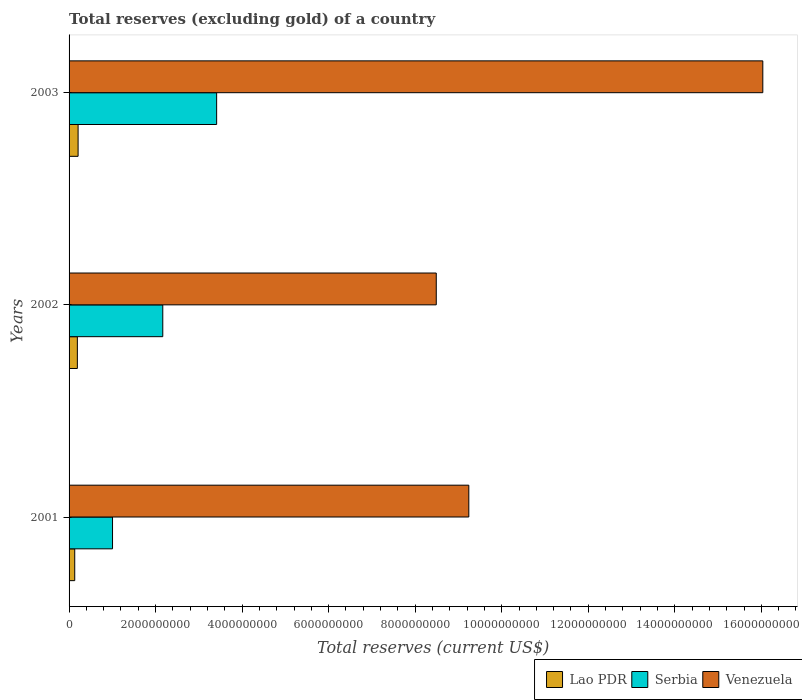How many groups of bars are there?
Offer a very short reply. 3. Are the number of bars per tick equal to the number of legend labels?
Keep it short and to the point. Yes. In how many cases, is the number of bars for a given year not equal to the number of legend labels?
Your response must be concise. 0. What is the total reserves (excluding gold) in Lao PDR in 2001?
Ensure brevity in your answer.  1.31e+08. Across all years, what is the maximum total reserves (excluding gold) in Venezuela?
Keep it short and to the point. 1.60e+1. Across all years, what is the minimum total reserves (excluding gold) in Serbia?
Provide a succinct answer. 1.00e+09. In which year was the total reserves (excluding gold) in Serbia maximum?
Your answer should be very brief. 2003. In which year was the total reserves (excluding gold) in Lao PDR minimum?
Offer a very short reply. 2001. What is the total total reserves (excluding gold) in Serbia in the graph?
Your answer should be compact. 6.58e+09. What is the difference between the total reserves (excluding gold) in Serbia in 2001 and that in 2003?
Ensure brevity in your answer.  -2.41e+09. What is the difference between the total reserves (excluding gold) in Venezuela in 2003 and the total reserves (excluding gold) in Lao PDR in 2002?
Ensure brevity in your answer.  1.58e+1. What is the average total reserves (excluding gold) in Lao PDR per year?
Make the answer very short. 1.77e+08. In the year 2001, what is the difference between the total reserves (excluding gold) in Serbia and total reserves (excluding gold) in Lao PDR?
Keep it short and to the point. 8.74e+08. What is the ratio of the total reserves (excluding gold) in Serbia in 2001 to that in 2003?
Keep it short and to the point. 0.29. Is the total reserves (excluding gold) in Lao PDR in 2001 less than that in 2003?
Provide a short and direct response. Yes. What is the difference between the highest and the second highest total reserves (excluding gold) in Venezuela?
Offer a terse response. 6.80e+09. What is the difference between the highest and the lowest total reserves (excluding gold) in Serbia?
Your response must be concise. 2.41e+09. In how many years, is the total reserves (excluding gold) in Venezuela greater than the average total reserves (excluding gold) in Venezuela taken over all years?
Ensure brevity in your answer.  1. Is the sum of the total reserves (excluding gold) in Venezuela in 2001 and 2002 greater than the maximum total reserves (excluding gold) in Lao PDR across all years?
Make the answer very short. Yes. What does the 2nd bar from the top in 2003 represents?
Provide a succinct answer. Serbia. What does the 2nd bar from the bottom in 2001 represents?
Ensure brevity in your answer.  Serbia. Is it the case that in every year, the sum of the total reserves (excluding gold) in Serbia and total reserves (excluding gold) in Lao PDR is greater than the total reserves (excluding gold) in Venezuela?
Provide a succinct answer. No. What is the difference between two consecutive major ticks on the X-axis?
Give a very brief answer. 2.00e+09. Are the values on the major ticks of X-axis written in scientific E-notation?
Ensure brevity in your answer.  No. Does the graph contain any zero values?
Ensure brevity in your answer.  No. How are the legend labels stacked?
Ensure brevity in your answer.  Horizontal. What is the title of the graph?
Offer a very short reply. Total reserves (excluding gold) of a country. What is the label or title of the X-axis?
Provide a succinct answer. Total reserves (current US$). What is the label or title of the Y-axis?
Offer a very short reply. Years. What is the Total reserves (current US$) in Lao PDR in 2001?
Offer a terse response. 1.31e+08. What is the Total reserves (current US$) in Serbia in 2001?
Provide a short and direct response. 1.00e+09. What is the Total reserves (current US$) of Venezuela in 2001?
Ensure brevity in your answer.  9.24e+09. What is the Total reserves (current US$) of Lao PDR in 2002?
Keep it short and to the point. 1.92e+08. What is the Total reserves (current US$) in Serbia in 2002?
Offer a very short reply. 2.17e+09. What is the Total reserves (current US$) of Venezuela in 2002?
Your answer should be compact. 8.49e+09. What is the Total reserves (current US$) of Lao PDR in 2003?
Offer a terse response. 2.09e+08. What is the Total reserves (current US$) in Serbia in 2003?
Your response must be concise. 3.41e+09. What is the Total reserves (current US$) of Venezuela in 2003?
Provide a short and direct response. 1.60e+1. Across all years, what is the maximum Total reserves (current US$) in Lao PDR?
Provide a short and direct response. 2.09e+08. Across all years, what is the maximum Total reserves (current US$) of Serbia?
Give a very brief answer. 3.41e+09. Across all years, what is the maximum Total reserves (current US$) of Venezuela?
Provide a short and direct response. 1.60e+1. Across all years, what is the minimum Total reserves (current US$) of Lao PDR?
Your response must be concise. 1.31e+08. Across all years, what is the minimum Total reserves (current US$) in Serbia?
Ensure brevity in your answer.  1.00e+09. Across all years, what is the minimum Total reserves (current US$) in Venezuela?
Offer a terse response. 8.49e+09. What is the total Total reserves (current US$) of Lao PDR in the graph?
Your response must be concise. 5.31e+08. What is the total Total reserves (current US$) in Serbia in the graph?
Give a very brief answer. 6.58e+09. What is the total Total reserves (current US$) of Venezuela in the graph?
Your answer should be very brief. 3.38e+1. What is the difference between the Total reserves (current US$) of Lao PDR in 2001 and that in 2002?
Provide a short and direct response. -6.07e+07. What is the difference between the Total reserves (current US$) of Serbia in 2001 and that in 2002?
Offer a terse response. -1.16e+09. What is the difference between the Total reserves (current US$) in Venezuela in 2001 and that in 2002?
Ensure brevity in your answer.  7.52e+08. What is the difference between the Total reserves (current US$) of Lao PDR in 2001 and that in 2003?
Ensure brevity in your answer.  -7.77e+07. What is the difference between the Total reserves (current US$) of Serbia in 2001 and that in 2003?
Your response must be concise. -2.41e+09. What is the difference between the Total reserves (current US$) in Venezuela in 2001 and that in 2003?
Ensure brevity in your answer.  -6.80e+09. What is the difference between the Total reserves (current US$) of Lao PDR in 2002 and that in 2003?
Your response must be concise. -1.70e+07. What is the difference between the Total reserves (current US$) of Serbia in 2002 and that in 2003?
Offer a very short reply. -1.24e+09. What is the difference between the Total reserves (current US$) of Venezuela in 2002 and that in 2003?
Keep it short and to the point. -7.55e+09. What is the difference between the Total reserves (current US$) in Lao PDR in 2001 and the Total reserves (current US$) in Serbia in 2002?
Your answer should be compact. -2.04e+09. What is the difference between the Total reserves (current US$) in Lao PDR in 2001 and the Total reserves (current US$) in Venezuela in 2002?
Give a very brief answer. -8.36e+09. What is the difference between the Total reserves (current US$) of Serbia in 2001 and the Total reserves (current US$) of Venezuela in 2002?
Ensure brevity in your answer.  -7.48e+09. What is the difference between the Total reserves (current US$) in Lao PDR in 2001 and the Total reserves (current US$) in Serbia in 2003?
Ensure brevity in your answer.  -3.28e+09. What is the difference between the Total reserves (current US$) of Lao PDR in 2001 and the Total reserves (current US$) of Venezuela in 2003?
Provide a short and direct response. -1.59e+1. What is the difference between the Total reserves (current US$) of Serbia in 2001 and the Total reserves (current US$) of Venezuela in 2003?
Your answer should be compact. -1.50e+1. What is the difference between the Total reserves (current US$) of Lao PDR in 2002 and the Total reserves (current US$) of Serbia in 2003?
Offer a very short reply. -3.22e+09. What is the difference between the Total reserves (current US$) of Lao PDR in 2002 and the Total reserves (current US$) of Venezuela in 2003?
Your answer should be very brief. -1.58e+1. What is the difference between the Total reserves (current US$) in Serbia in 2002 and the Total reserves (current US$) in Venezuela in 2003?
Offer a terse response. -1.39e+1. What is the average Total reserves (current US$) in Lao PDR per year?
Provide a succinct answer. 1.77e+08. What is the average Total reserves (current US$) in Serbia per year?
Give a very brief answer. 2.19e+09. What is the average Total reserves (current US$) of Venezuela per year?
Give a very brief answer. 1.13e+1. In the year 2001, what is the difference between the Total reserves (current US$) in Lao PDR and Total reserves (current US$) in Serbia?
Offer a very short reply. -8.74e+08. In the year 2001, what is the difference between the Total reserves (current US$) in Lao PDR and Total reserves (current US$) in Venezuela?
Your answer should be very brief. -9.11e+09. In the year 2001, what is the difference between the Total reserves (current US$) in Serbia and Total reserves (current US$) in Venezuela?
Give a very brief answer. -8.23e+09. In the year 2002, what is the difference between the Total reserves (current US$) in Lao PDR and Total reserves (current US$) in Serbia?
Offer a very short reply. -1.97e+09. In the year 2002, what is the difference between the Total reserves (current US$) in Lao PDR and Total reserves (current US$) in Venezuela?
Offer a very short reply. -8.30e+09. In the year 2002, what is the difference between the Total reserves (current US$) in Serbia and Total reserves (current US$) in Venezuela?
Make the answer very short. -6.32e+09. In the year 2003, what is the difference between the Total reserves (current US$) of Lao PDR and Total reserves (current US$) of Serbia?
Keep it short and to the point. -3.20e+09. In the year 2003, what is the difference between the Total reserves (current US$) of Lao PDR and Total reserves (current US$) of Venezuela?
Provide a short and direct response. -1.58e+1. In the year 2003, what is the difference between the Total reserves (current US$) in Serbia and Total reserves (current US$) in Venezuela?
Your response must be concise. -1.26e+1. What is the ratio of the Total reserves (current US$) in Lao PDR in 2001 to that in 2002?
Give a very brief answer. 0.68. What is the ratio of the Total reserves (current US$) of Serbia in 2001 to that in 2002?
Provide a succinct answer. 0.46. What is the ratio of the Total reserves (current US$) of Venezuela in 2001 to that in 2002?
Make the answer very short. 1.09. What is the ratio of the Total reserves (current US$) in Lao PDR in 2001 to that in 2003?
Offer a terse response. 0.63. What is the ratio of the Total reserves (current US$) of Serbia in 2001 to that in 2003?
Make the answer very short. 0.29. What is the ratio of the Total reserves (current US$) in Venezuela in 2001 to that in 2003?
Keep it short and to the point. 0.58. What is the ratio of the Total reserves (current US$) of Lao PDR in 2002 to that in 2003?
Give a very brief answer. 0.92. What is the ratio of the Total reserves (current US$) in Serbia in 2002 to that in 2003?
Provide a short and direct response. 0.64. What is the ratio of the Total reserves (current US$) of Venezuela in 2002 to that in 2003?
Your answer should be compact. 0.53. What is the difference between the highest and the second highest Total reserves (current US$) in Lao PDR?
Offer a very short reply. 1.70e+07. What is the difference between the highest and the second highest Total reserves (current US$) in Serbia?
Your answer should be compact. 1.24e+09. What is the difference between the highest and the second highest Total reserves (current US$) in Venezuela?
Keep it short and to the point. 6.80e+09. What is the difference between the highest and the lowest Total reserves (current US$) in Lao PDR?
Make the answer very short. 7.77e+07. What is the difference between the highest and the lowest Total reserves (current US$) in Serbia?
Provide a short and direct response. 2.41e+09. What is the difference between the highest and the lowest Total reserves (current US$) in Venezuela?
Your answer should be very brief. 7.55e+09. 